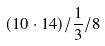Convert formula to latex. <formula><loc_0><loc_0><loc_500><loc_500>( 1 0 \cdot 1 4 ) / \frac { 1 } { 3 } / 8</formula> 